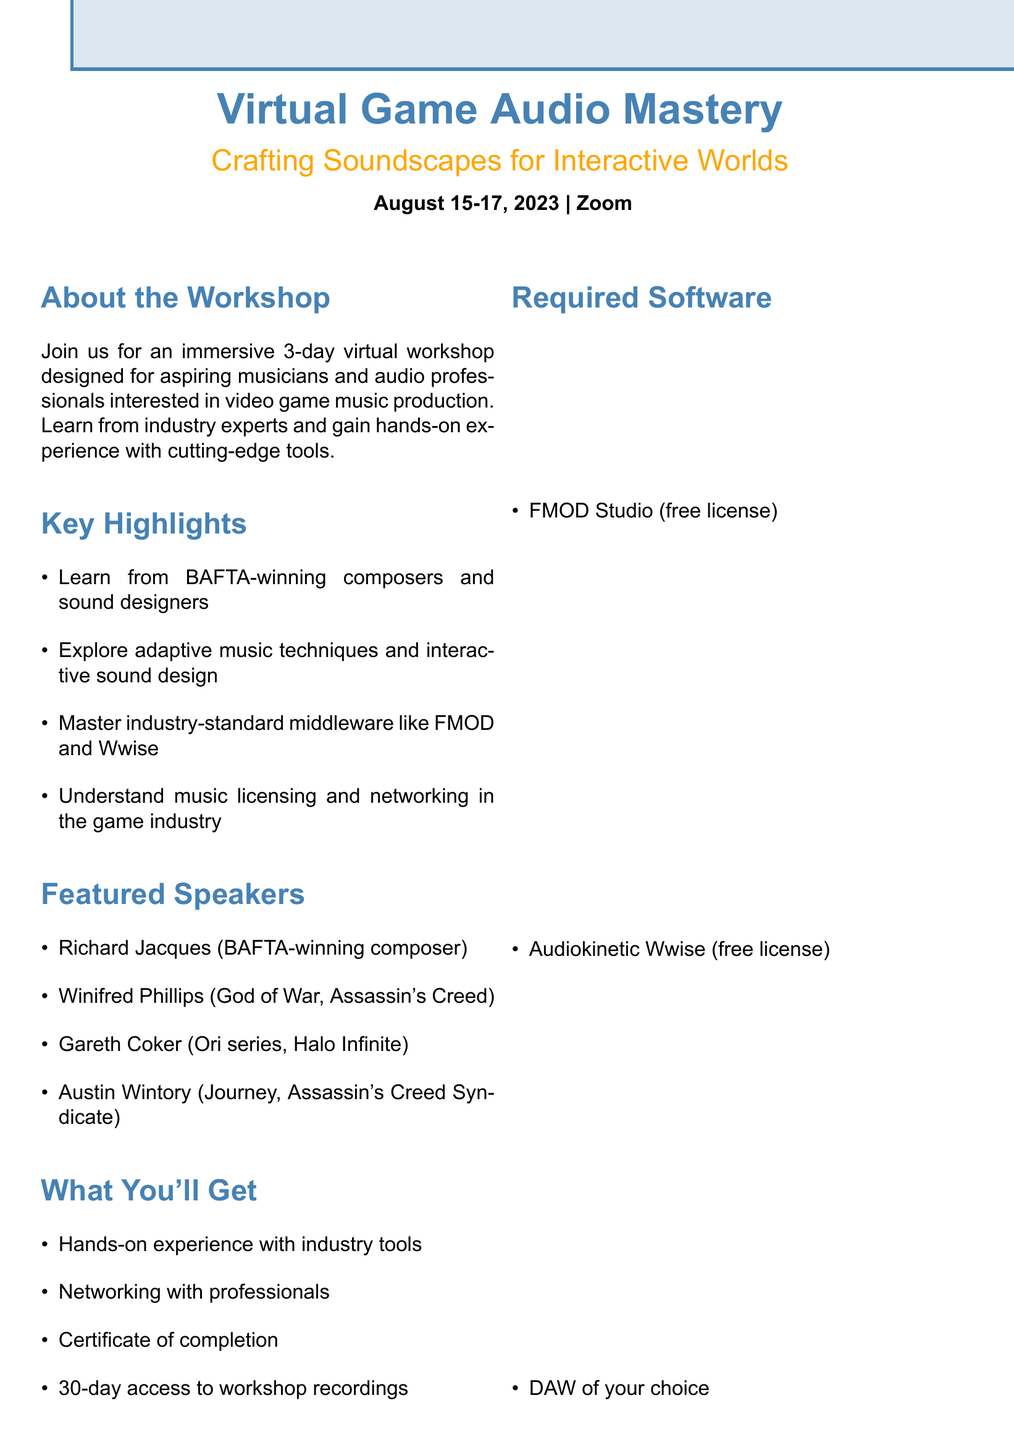What is the workshop title? The workshop title is provided at the beginning of the document, which is "Virtual Game Audio Mastery: Crafting Soundscapes for Interactive Worlds."
Answer: Virtual Game Audio Mastery: Crafting Soundscapes for Interactive Worlds When is the workshop scheduled? The document states the dates of the workshop, which are from August 15 to August 17, 2023.
Answer: August 15-17, 2023 What platform will the workshop take place on? The platform for the workshop is mentioned in the document.
Answer: Zoom What is the early bird registration fee? The early bird registration fee is specified in the document, which states that it's available until July 15.
Answer: $99 Who is the speaker for the session on "Adaptive Music Techniques"? The document lists the speakers for each session, including the one on "Adaptive Music Techniques."
Answer: Winifred Phillips What session is scheduled at 2:00 PM on Day 2? The schedule provides details of the sessions, including their timings and titles for each day.
Answer: Audio Implementation in Unreal Engine What will participants receive upon completion of the workshop? The document outlines the benefits of the workshop, including what participants will receive.
Answer: Certificate of completion How many days will the workshop last? The document specifies the duration of the workshop, stated clearly under the schedule section.
Answer: 3 days What is required to attend the workshop? The document lists the required software necessary for participants to attend the workshop.
Answer: FMOD Studio, Audiokinetic Wwise, DAW of choice 